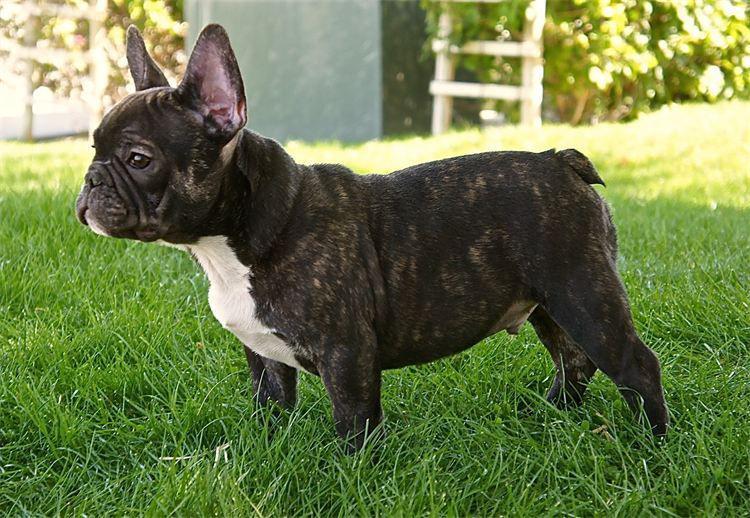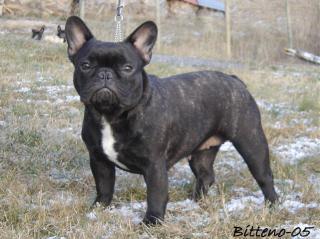The first image is the image on the left, the second image is the image on the right. For the images displayed, is the sentence "Each image contains a dark french bulldog in a sitting pose, and the dog in the left image has its body turned rightward while the dog on the right looks directly at the camera." factually correct? Answer yes or no. No. The first image is the image on the left, the second image is the image on the right. For the images displayed, is the sentence "All the dogs are sitting." factually correct? Answer yes or no. No. 